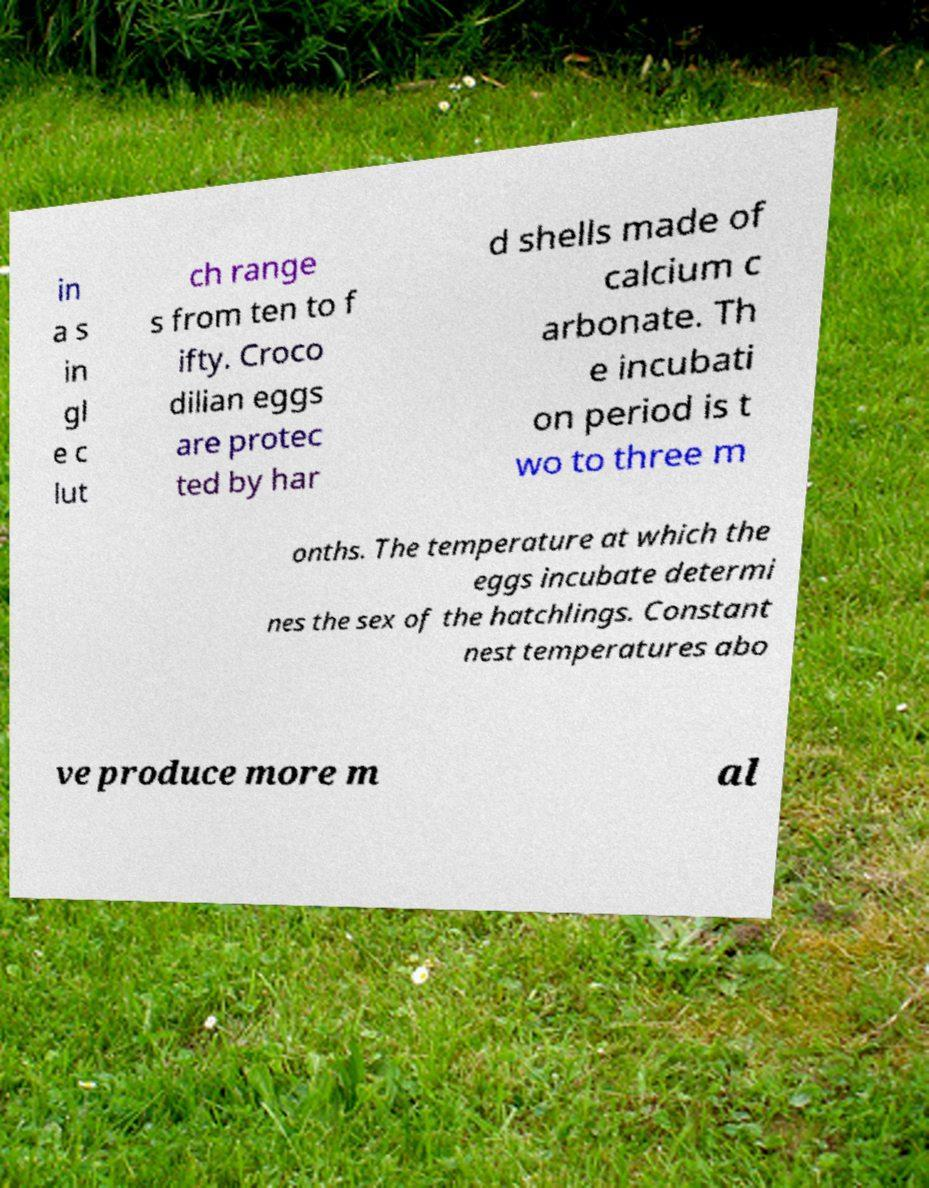Could you assist in decoding the text presented in this image and type it out clearly? in a s in gl e c lut ch range s from ten to f ifty. Croco dilian eggs are protec ted by har d shells made of calcium c arbonate. Th e incubati on period is t wo to three m onths. The temperature at which the eggs incubate determi nes the sex of the hatchlings. Constant nest temperatures abo ve produce more m al 